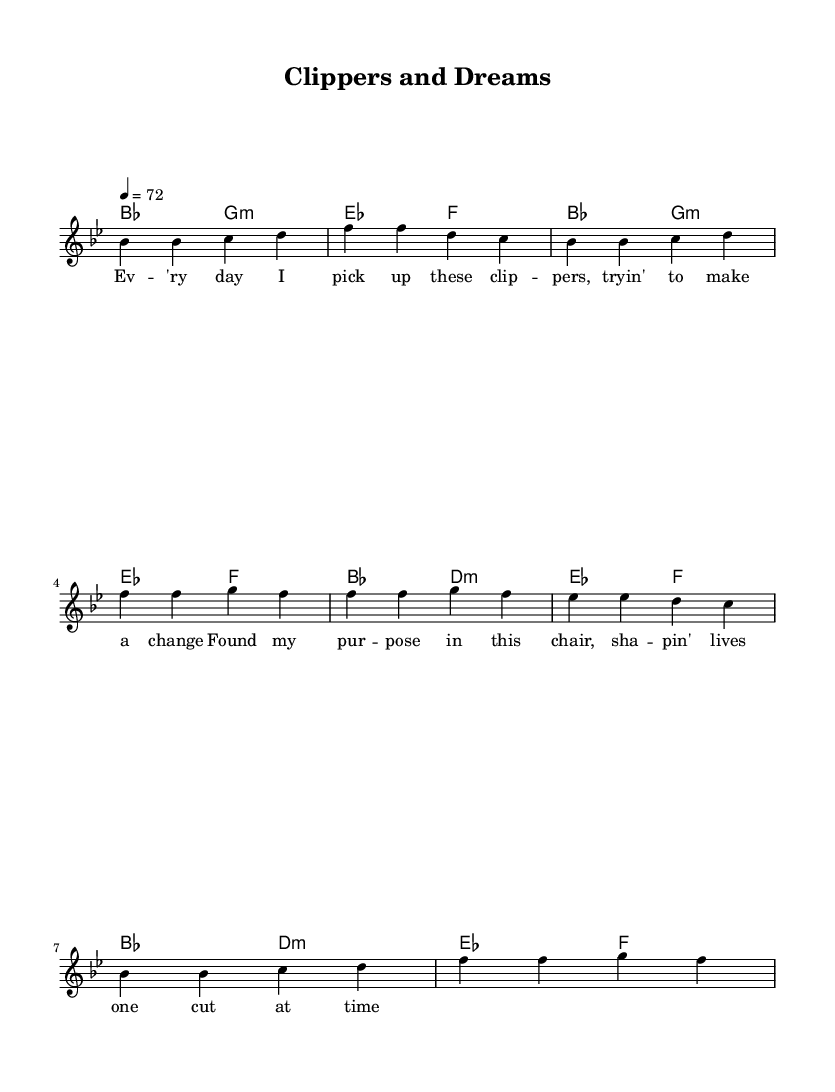What is the key signature of this music? The key signature is B flat major, which has two flats (B flat and E flat). This can be identified at the beginning of the sheet music.
Answer: B flat major What is the time signature of the music? The time signature is 4/4, which means there are four beats in each measure and the quarter note gets one beat. This is typically indicated at the beginning of the score.
Answer: 4/4 What is the tempo marking in the piece? The tempo marking is 72 beats per minute, indicated as "4 = 72" at the beginning of the score. This means the quarter note is counted at 72 beats in one minute.
Answer: 72 How many measures are there in the verse before the chorus starts? There are four measures in the verse section before the chorus begins, as indicated by the notation before the chorus lyrics and chords.
Answer: 4 Which chord follows the B flat chord in the verse? The G minor chord follows the B flat chord in the verse, as seen in the chord names section where the progression is laid out.
Answer: G minor What is the primary theme of the lyrics in this soul tune? The primary theme in the lyrics revolves around finding purpose in the everyday work of barbering and making a difference in others’ lives, as expressed in the phrases regarding shaping lives and change.
Answer: Finding purpose What type of music does this piece represent? This piece represents the genre of soul music, characterized by its emotional expression and themes of everyday experiences, love, and personal struggles found in the lyrics and style.
Answer: Soul 